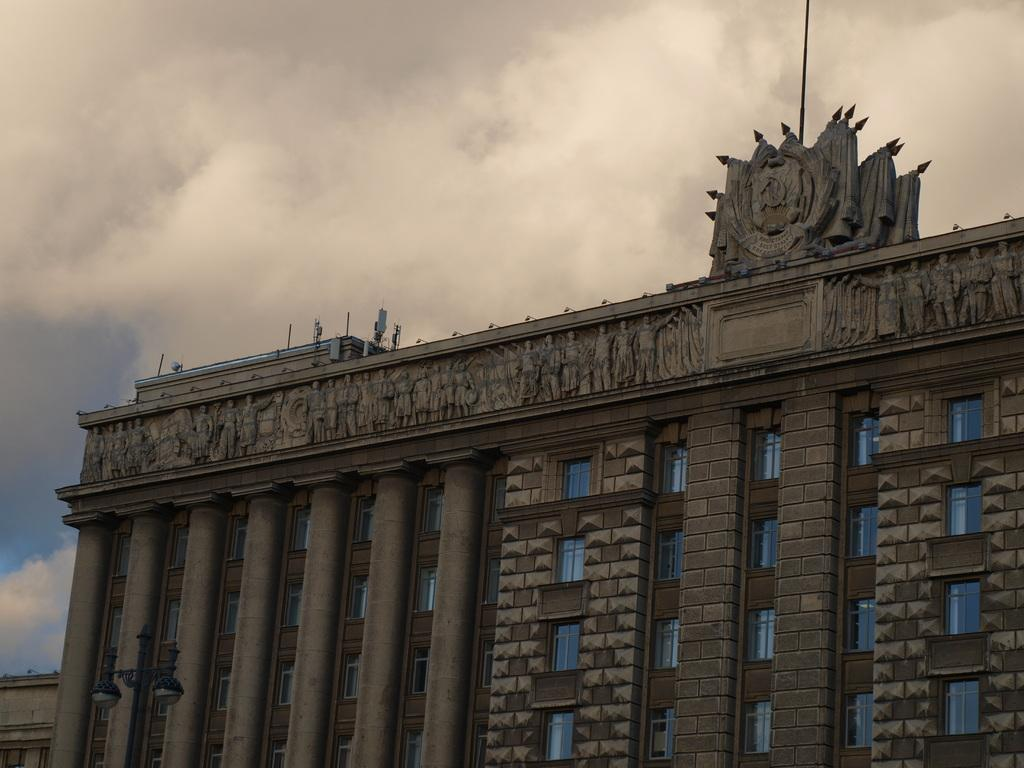What type of structures are located at the bottom of the image? There are buildings at the bottom of the image. What feature do the buildings have? The buildings have windows. What can be seen in the sky in the background of the image? There are clouds in the sky in the background of the image. What type of oatmeal is being weighed on the scale in the image? There is no oatmeal or scale present in the image. How many pumpkins are visible in the image? There are no pumpkins present in the image. 